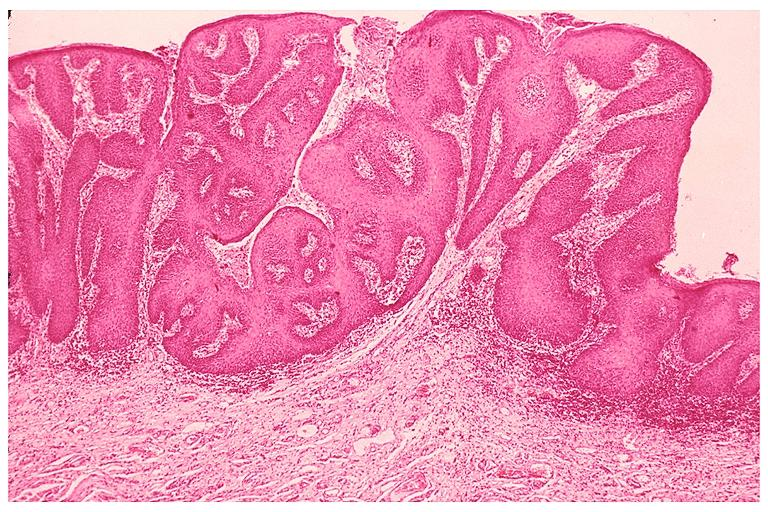does this image show inflamatory papillary hyperplasia?
Answer the question using a single word or phrase. Yes 